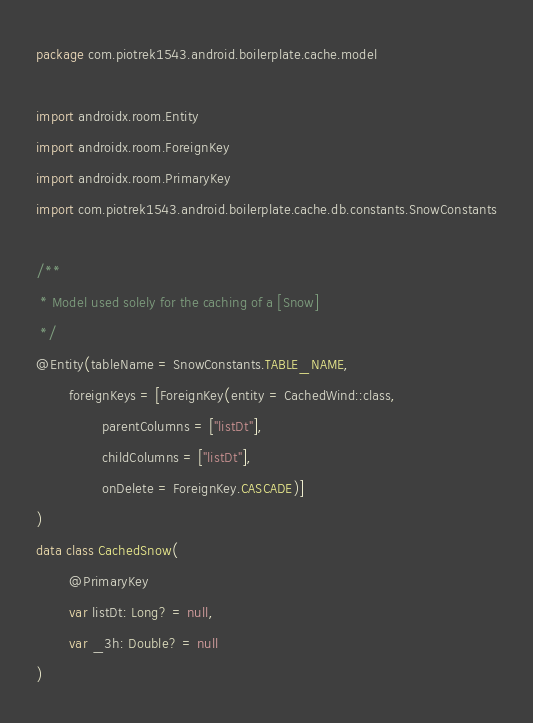Convert code to text. <code><loc_0><loc_0><loc_500><loc_500><_Kotlin_>package com.piotrek1543.android.boilerplate.cache.model

import androidx.room.Entity
import androidx.room.ForeignKey
import androidx.room.PrimaryKey
import com.piotrek1543.android.boilerplate.cache.db.constants.SnowConstants

/**
 * Model used solely for the caching of a [Snow]
 */
@Entity(tableName = SnowConstants.TABLE_NAME,
        foreignKeys = [ForeignKey(entity = CachedWind::class,
                parentColumns = ["listDt"],
                childColumns = ["listDt"],
                onDelete = ForeignKey.CASCADE)]
)
data class CachedSnow(
        @PrimaryKey
        var listDt: Long? = null,
        var _3h: Double? = null
)
</code> 